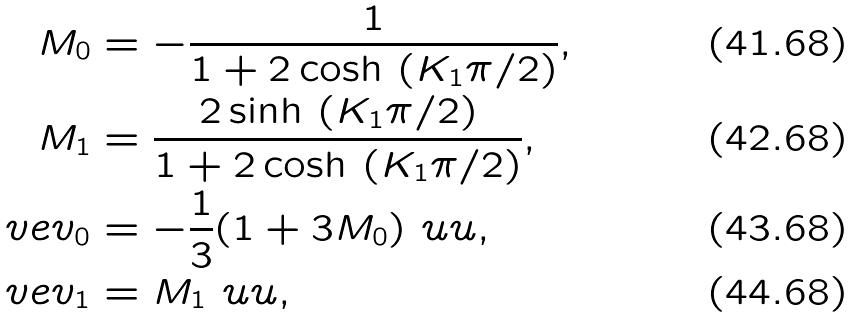<formula> <loc_0><loc_0><loc_500><loc_500>M _ { 0 } & = - \frac { 1 } { 1 + 2 \cosh \, \left ( K _ { 1 } \pi / 2 \right ) } , \\ M _ { 1 } & = \frac { 2 \sinh \, \left ( K _ { 1 } \pi / 2 \right ) } { 1 + 2 \cosh \, \left ( K _ { 1 } \pi / 2 \right ) } , \\ \ v e { v } _ { 0 } & = - \frac { 1 } { 3 } ( 1 + 3 M _ { 0 } ) \ u u , \\ \ v e { v } _ { 1 } & = M _ { 1 } \ u u ,</formula> 